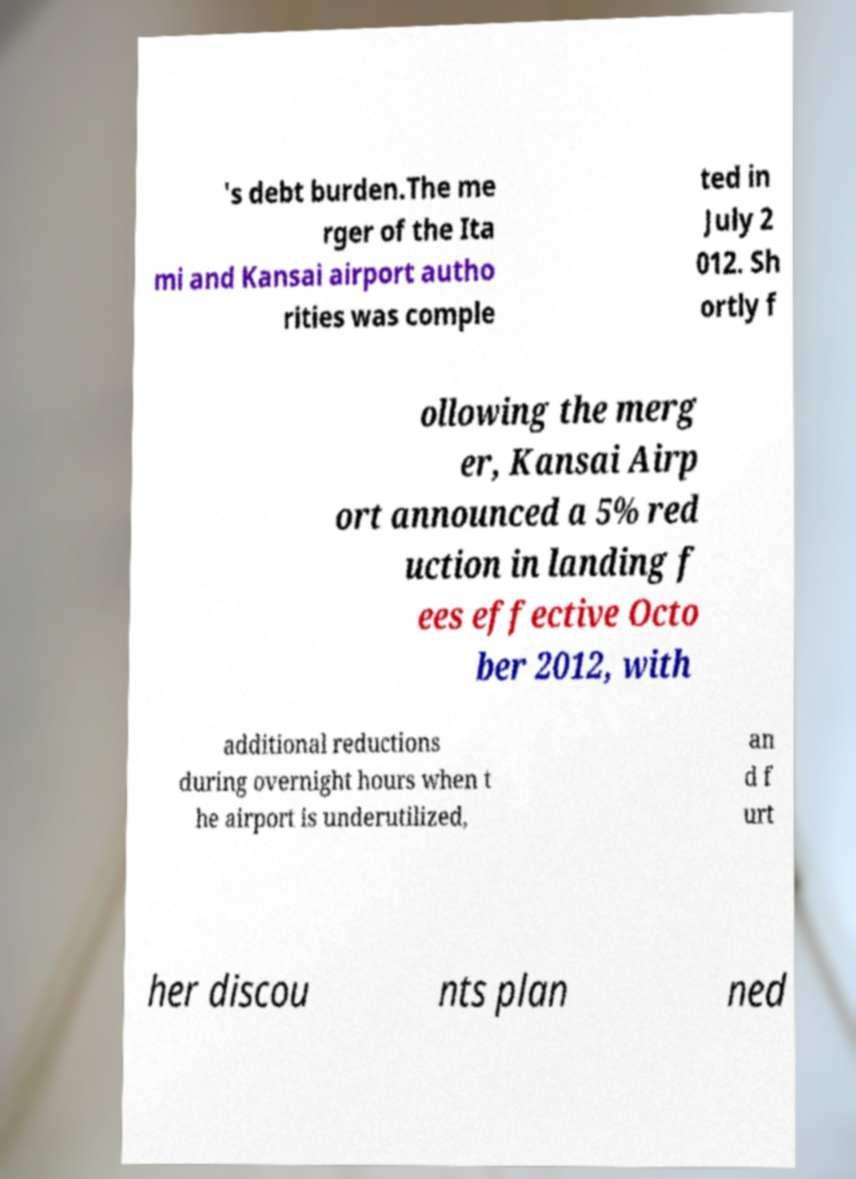For documentation purposes, I need the text within this image transcribed. Could you provide that? 's debt burden.The me rger of the Ita mi and Kansai airport autho rities was comple ted in July 2 012. Sh ortly f ollowing the merg er, Kansai Airp ort announced a 5% red uction in landing f ees effective Octo ber 2012, with additional reductions during overnight hours when t he airport is underutilized, an d f urt her discou nts plan ned 